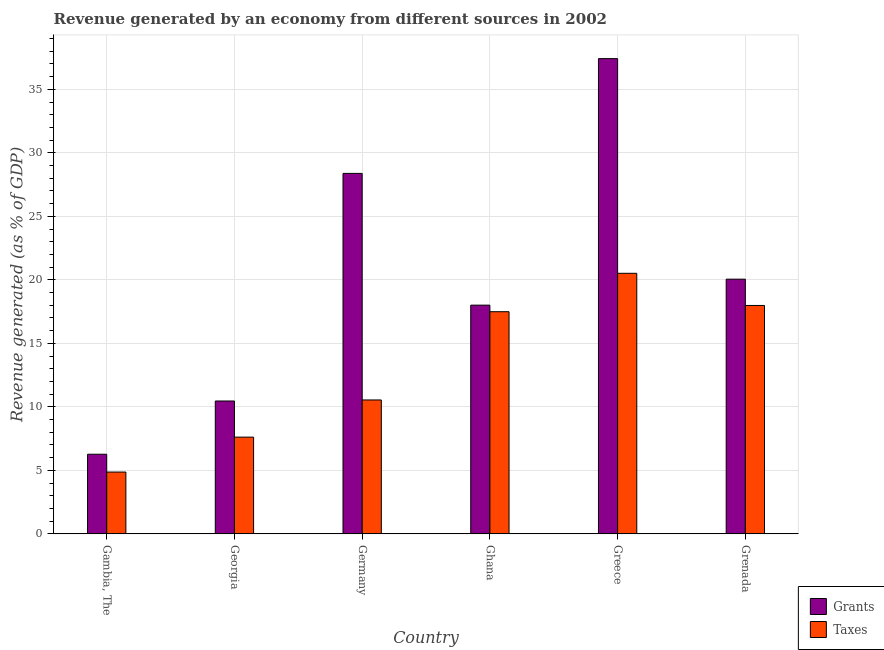How many bars are there on the 4th tick from the left?
Provide a succinct answer. 2. What is the label of the 2nd group of bars from the left?
Give a very brief answer. Georgia. In how many cases, is the number of bars for a given country not equal to the number of legend labels?
Your response must be concise. 0. What is the revenue generated by grants in Georgia?
Ensure brevity in your answer.  10.46. Across all countries, what is the maximum revenue generated by grants?
Offer a very short reply. 37.42. Across all countries, what is the minimum revenue generated by taxes?
Your answer should be very brief. 4.87. In which country was the revenue generated by grants maximum?
Provide a succinct answer. Greece. In which country was the revenue generated by grants minimum?
Provide a short and direct response. Gambia, The. What is the total revenue generated by grants in the graph?
Give a very brief answer. 120.61. What is the difference between the revenue generated by taxes in Georgia and that in Germany?
Your response must be concise. -2.93. What is the difference between the revenue generated by taxes in Georgia and the revenue generated by grants in Germany?
Make the answer very short. -20.77. What is the average revenue generated by grants per country?
Your answer should be very brief. 20.1. What is the difference between the revenue generated by grants and revenue generated by taxes in Germany?
Your answer should be very brief. 17.84. What is the ratio of the revenue generated by taxes in Georgia to that in Germany?
Your answer should be very brief. 0.72. What is the difference between the highest and the second highest revenue generated by grants?
Ensure brevity in your answer.  9.04. What is the difference between the highest and the lowest revenue generated by grants?
Provide a succinct answer. 31.15. In how many countries, is the revenue generated by grants greater than the average revenue generated by grants taken over all countries?
Offer a terse response. 2. What does the 1st bar from the left in Grenada represents?
Offer a very short reply. Grants. What does the 2nd bar from the right in Germany represents?
Keep it short and to the point. Grants. How many bars are there?
Provide a succinct answer. 12. Are all the bars in the graph horizontal?
Your answer should be compact. No. How many countries are there in the graph?
Offer a very short reply. 6. What is the difference between two consecutive major ticks on the Y-axis?
Provide a short and direct response. 5. Does the graph contain any zero values?
Your answer should be compact. No. Where does the legend appear in the graph?
Offer a terse response. Bottom right. How are the legend labels stacked?
Make the answer very short. Vertical. What is the title of the graph?
Offer a terse response. Revenue generated by an economy from different sources in 2002. Does "IMF nonconcessional" appear as one of the legend labels in the graph?
Your answer should be compact. No. What is the label or title of the Y-axis?
Provide a succinct answer. Revenue generated (as % of GDP). What is the Revenue generated (as % of GDP) of Grants in Gambia, The?
Give a very brief answer. 6.27. What is the Revenue generated (as % of GDP) of Taxes in Gambia, The?
Provide a short and direct response. 4.87. What is the Revenue generated (as % of GDP) of Grants in Georgia?
Provide a succinct answer. 10.46. What is the Revenue generated (as % of GDP) of Taxes in Georgia?
Your response must be concise. 7.62. What is the Revenue generated (as % of GDP) in Grants in Germany?
Ensure brevity in your answer.  28.39. What is the Revenue generated (as % of GDP) in Taxes in Germany?
Provide a short and direct response. 10.54. What is the Revenue generated (as % of GDP) in Grants in Ghana?
Make the answer very short. 18.01. What is the Revenue generated (as % of GDP) in Taxes in Ghana?
Provide a succinct answer. 17.49. What is the Revenue generated (as % of GDP) of Grants in Greece?
Your answer should be compact. 37.42. What is the Revenue generated (as % of GDP) in Taxes in Greece?
Your response must be concise. 20.52. What is the Revenue generated (as % of GDP) of Grants in Grenada?
Give a very brief answer. 20.06. What is the Revenue generated (as % of GDP) of Taxes in Grenada?
Give a very brief answer. 17.99. Across all countries, what is the maximum Revenue generated (as % of GDP) in Grants?
Offer a very short reply. 37.42. Across all countries, what is the maximum Revenue generated (as % of GDP) in Taxes?
Give a very brief answer. 20.52. Across all countries, what is the minimum Revenue generated (as % of GDP) in Grants?
Give a very brief answer. 6.27. Across all countries, what is the minimum Revenue generated (as % of GDP) of Taxes?
Provide a short and direct response. 4.87. What is the total Revenue generated (as % of GDP) of Grants in the graph?
Give a very brief answer. 120.61. What is the total Revenue generated (as % of GDP) in Taxes in the graph?
Offer a terse response. 79.03. What is the difference between the Revenue generated (as % of GDP) in Grants in Gambia, The and that in Georgia?
Provide a short and direct response. -4.19. What is the difference between the Revenue generated (as % of GDP) in Taxes in Gambia, The and that in Georgia?
Your response must be concise. -2.75. What is the difference between the Revenue generated (as % of GDP) of Grants in Gambia, The and that in Germany?
Your response must be concise. -22.12. What is the difference between the Revenue generated (as % of GDP) in Taxes in Gambia, The and that in Germany?
Keep it short and to the point. -5.68. What is the difference between the Revenue generated (as % of GDP) in Grants in Gambia, The and that in Ghana?
Your response must be concise. -11.74. What is the difference between the Revenue generated (as % of GDP) in Taxes in Gambia, The and that in Ghana?
Offer a very short reply. -12.63. What is the difference between the Revenue generated (as % of GDP) of Grants in Gambia, The and that in Greece?
Provide a succinct answer. -31.15. What is the difference between the Revenue generated (as % of GDP) of Taxes in Gambia, The and that in Greece?
Offer a very short reply. -15.65. What is the difference between the Revenue generated (as % of GDP) in Grants in Gambia, The and that in Grenada?
Your answer should be compact. -13.79. What is the difference between the Revenue generated (as % of GDP) of Taxes in Gambia, The and that in Grenada?
Your answer should be compact. -13.12. What is the difference between the Revenue generated (as % of GDP) in Grants in Georgia and that in Germany?
Ensure brevity in your answer.  -17.92. What is the difference between the Revenue generated (as % of GDP) of Taxes in Georgia and that in Germany?
Provide a short and direct response. -2.93. What is the difference between the Revenue generated (as % of GDP) in Grants in Georgia and that in Ghana?
Provide a succinct answer. -7.55. What is the difference between the Revenue generated (as % of GDP) of Taxes in Georgia and that in Ghana?
Your answer should be very brief. -9.88. What is the difference between the Revenue generated (as % of GDP) in Grants in Georgia and that in Greece?
Your answer should be very brief. -26.96. What is the difference between the Revenue generated (as % of GDP) in Taxes in Georgia and that in Greece?
Keep it short and to the point. -12.9. What is the difference between the Revenue generated (as % of GDP) in Grants in Georgia and that in Grenada?
Offer a very short reply. -9.59. What is the difference between the Revenue generated (as % of GDP) of Taxes in Georgia and that in Grenada?
Your response must be concise. -10.37. What is the difference between the Revenue generated (as % of GDP) in Grants in Germany and that in Ghana?
Your answer should be compact. 10.38. What is the difference between the Revenue generated (as % of GDP) of Taxes in Germany and that in Ghana?
Provide a succinct answer. -6.95. What is the difference between the Revenue generated (as % of GDP) of Grants in Germany and that in Greece?
Provide a short and direct response. -9.04. What is the difference between the Revenue generated (as % of GDP) in Taxes in Germany and that in Greece?
Make the answer very short. -9.97. What is the difference between the Revenue generated (as % of GDP) in Grants in Germany and that in Grenada?
Ensure brevity in your answer.  8.33. What is the difference between the Revenue generated (as % of GDP) of Taxes in Germany and that in Grenada?
Ensure brevity in your answer.  -7.44. What is the difference between the Revenue generated (as % of GDP) of Grants in Ghana and that in Greece?
Your answer should be compact. -19.41. What is the difference between the Revenue generated (as % of GDP) of Taxes in Ghana and that in Greece?
Offer a terse response. -3.02. What is the difference between the Revenue generated (as % of GDP) of Grants in Ghana and that in Grenada?
Your answer should be compact. -2.05. What is the difference between the Revenue generated (as % of GDP) of Taxes in Ghana and that in Grenada?
Keep it short and to the point. -0.49. What is the difference between the Revenue generated (as % of GDP) in Grants in Greece and that in Grenada?
Give a very brief answer. 17.37. What is the difference between the Revenue generated (as % of GDP) in Taxes in Greece and that in Grenada?
Offer a very short reply. 2.53. What is the difference between the Revenue generated (as % of GDP) of Grants in Gambia, The and the Revenue generated (as % of GDP) of Taxes in Georgia?
Your answer should be very brief. -1.35. What is the difference between the Revenue generated (as % of GDP) in Grants in Gambia, The and the Revenue generated (as % of GDP) in Taxes in Germany?
Offer a terse response. -4.27. What is the difference between the Revenue generated (as % of GDP) in Grants in Gambia, The and the Revenue generated (as % of GDP) in Taxes in Ghana?
Your answer should be very brief. -11.22. What is the difference between the Revenue generated (as % of GDP) of Grants in Gambia, The and the Revenue generated (as % of GDP) of Taxes in Greece?
Offer a terse response. -14.25. What is the difference between the Revenue generated (as % of GDP) in Grants in Gambia, The and the Revenue generated (as % of GDP) in Taxes in Grenada?
Offer a terse response. -11.72. What is the difference between the Revenue generated (as % of GDP) in Grants in Georgia and the Revenue generated (as % of GDP) in Taxes in Germany?
Give a very brief answer. -0.08. What is the difference between the Revenue generated (as % of GDP) in Grants in Georgia and the Revenue generated (as % of GDP) in Taxes in Ghana?
Your answer should be very brief. -7.03. What is the difference between the Revenue generated (as % of GDP) in Grants in Georgia and the Revenue generated (as % of GDP) in Taxes in Greece?
Your answer should be compact. -10.05. What is the difference between the Revenue generated (as % of GDP) in Grants in Georgia and the Revenue generated (as % of GDP) in Taxes in Grenada?
Your answer should be very brief. -7.52. What is the difference between the Revenue generated (as % of GDP) in Grants in Germany and the Revenue generated (as % of GDP) in Taxes in Ghana?
Your answer should be very brief. 10.89. What is the difference between the Revenue generated (as % of GDP) in Grants in Germany and the Revenue generated (as % of GDP) in Taxes in Greece?
Ensure brevity in your answer.  7.87. What is the difference between the Revenue generated (as % of GDP) in Grants in Germany and the Revenue generated (as % of GDP) in Taxes in Grenada?
Provide a succinct answer. 10.4. What is the difference between the Revenue generated (as % of GDP) of Grants in Ghana and the Revenue generated (as % of GDP) of Taxes in Greece?
Make the answer very short. -2.51. What is the difference between the Revenue generated (as % of GDP) of Grants in Ghana and the Revenue generated (as % of GDP) of Taxes in Grenada?
Make the answer very short. 0.02. What is the difference between the Revenue generated (as % of GDP) of Grants in Greece and the Revenue generated (as % of GDP) of Taxes in Grenada?
Your response must be concise. 19.44. What is the average Revenue generated (as % of GDP) of Grants per country?
Ensure brevity in your answer.  20.1. What is the average Revenue generated (as % of GDP) of Taxes per country?
Offer a terse response. 13.17. What is the difference between the Revenue generated (as % of GDP) of Grants and Revenue generated (as % of GDP) of Taxes in Gambia, The?
Make the answer very short. 1.4. What is the difference between the Revenue generated (as % of GDP) in Grants and Revenue generated (as % of GDP) in Taxes in Georgia?
Offer a terse response. 2.85. What is the difference between the Revenue generated (as % of GDP) of Grants and Revenue generated (as % of GDP) of Taxes in Germany?
Your response must be concise. 17.84. What is the difference between the Revenue generated (as % of GDP) in Grants and Revenue generated (as % of GDP) in Taxes in Ghana?
Give a very brief answer. 0.52. What is the difference between the Revenue generated (as % of GDP) in Grants and Revenue generated (as % of GDP) in Taxes in Greece?
Keep it short and to the point. 16.9. What is the difference between the Revenue generated (as % of GDP) of Grants and Revenue generated (as % of GDP) of Taxes in Grenada?
Your answer should be very brief. 2.07. What is the ratio of the Revenue generated (as % of GDP) of Grants in Gambia, The to that in Georgia?
Offer a terse response. 0.6. What is the ratio of the Revenue generated (as % of GDP) in Taxes in Gambia, The to that in Georgia?
Your response must be concise. 0.64. What is the ratio of the Revenue generated (as % of GDP) in Grants in Gambia, The to that in Germany?
Provide a short and direct response. 0.22. What is the ratio of the Revenue generated (as % of GDP) of Taxes in Gambia, The to that in Germany?
Ensure brevity in your answer.  0.46. What is the ratio of the Revenue generated (as % of GDP) in Grants in Gambia, The to that in Ghana?
Ensure brevity in your answer.  0.35. What is the ratio of the Revenue generated (as % of GDP) of Taxes in Gambia, The to that in Ghana?
Your answer should be very brief. 0.28. What is the ratio of the Revenue generated (as % of GDP) in Grants in Gambia, The to that in Greece?
Provide a short and direct response. 0.17. What is the ratio of the Revenue generated (as % of GDP) in Taxes in Gambia, The to that in Greece?
Offer a terse response. 0.24. What is the ratio of the Revenue generated (as % of GDP) of Grants in Gambia, The to that in Grenada?
Ensure brevity in your answer.  0.31. What is the ratio of the Revenue generated (as % of GDP) in Taxes in Gambia, The to that in Grenada?
Provide a short and direct response. 0.27. What is the ratio of the Revenue generated (as % of GDP) in Grants in Georgia to that in Germany?
Give a very brief answer. 0.37. What is the ratio of the Revenue generated (as % of GDP) of Taxes in Georgia to that in Germany?
Keep it short and to the point. 0.72. What is the ratio of the Revenue generated (as % of GDP) in Grants in Georgia to that in Ghana?
Give a very brief answer. 0.58. What is the ratio of the Revenue generated (as % of GDP) in Taxes in Georgia to that in Ghana?
Provide a short and direct response. 0.44. What is the ratio of the Revenue generated (as % of GDP) in Grants in Georgia to that in Greece?
Give a very brief answer. 0.28. What is the ratio of the Revenue generated (as % of GDP) in Taxes in Georgia to that in Greece?
Provide a succinct answer. 0.37. What is the ratio of the Revenue generated (as % of GDP) in Grants in Georgia to that in Grenada?
Make the answer very short. 0.52. What is the ratio of the Revenue generated (as % of GDP) in Taxes in Georgia to that in Grenada?
Make the answer very short. 0.42. What is the ratio of the Revenue generated (as % of GDP) of Grants in Germany to that in Ghana?
Give a very brief answer. 1.58. What is the ratio of the Revenue generated (as % of GDP) of Taxes in Germany to that in Ghana?
Your response must be concise. 0.6. What is the ratio of the Revenue generated (as % of GDP) in Grants in Germany to that in Greece?
Your answer should be compact. 0.76. What is the ratio of the Revenue generated (as % of GDP) of Taxes in Germany to that in Greece?
Provide a short and direct response. 0.51. What is the ratio of the Revenue generated (as % of GDP) in Grants in Germany to that in Grenada?
Your answer should be very brief. 1.42. What is the ratio of the Revenue generated (as % of GDP) of Taxes in Germany to that in Grenada?
Provide a succinct answer. 0.59. What is the ratio of the Revenue generated (as % of GDP) in Grants in Ghana to that in Greece?
Give a very brief answer. 0.48. What is the ratio of the Revenue generated (as % of GDP) of Taxes in Ghana to that in Greece?
Offer a terse response. 0.85. What is the ratio of the Revenue generated (as % of GDP) of Grants in Ghana to that in Grenada?
Make the answer very short. 0.9. What is the ratio of the Revenue generated (as % of GDP) of Taxes in Ghana to that in Grenada?
Ensure brevity in your answer.  0.97. What is the ratio of the Revenue generated (as % of GDP) in Grants in Greece to that in Grenada?
Provide a short and direct response. 1.87. What is the ratio of the Revenue generated (as % of GDP) of Taxes in Greece to that in Grenada?
Provide a succinct answer. 1.14. What is the difference between the highest and the second highest Revenue generated (as % of GDP) in Grants?
Ensure brevity in your answer.  9.04. What is the difference between the highest and the second highest Revenue generated (as % of GDP) in Taxes?
Your answer should be very brief. 2.53. What is the difference between the highest and the lowest Revenue generated (as % of GDP) of Grants?
Keep it short and to the point. 31.15. What is the difference between the highest and the lowest Revenue generated (as % of GDP) of Taxes?
Your response must be concise. 15.65. 